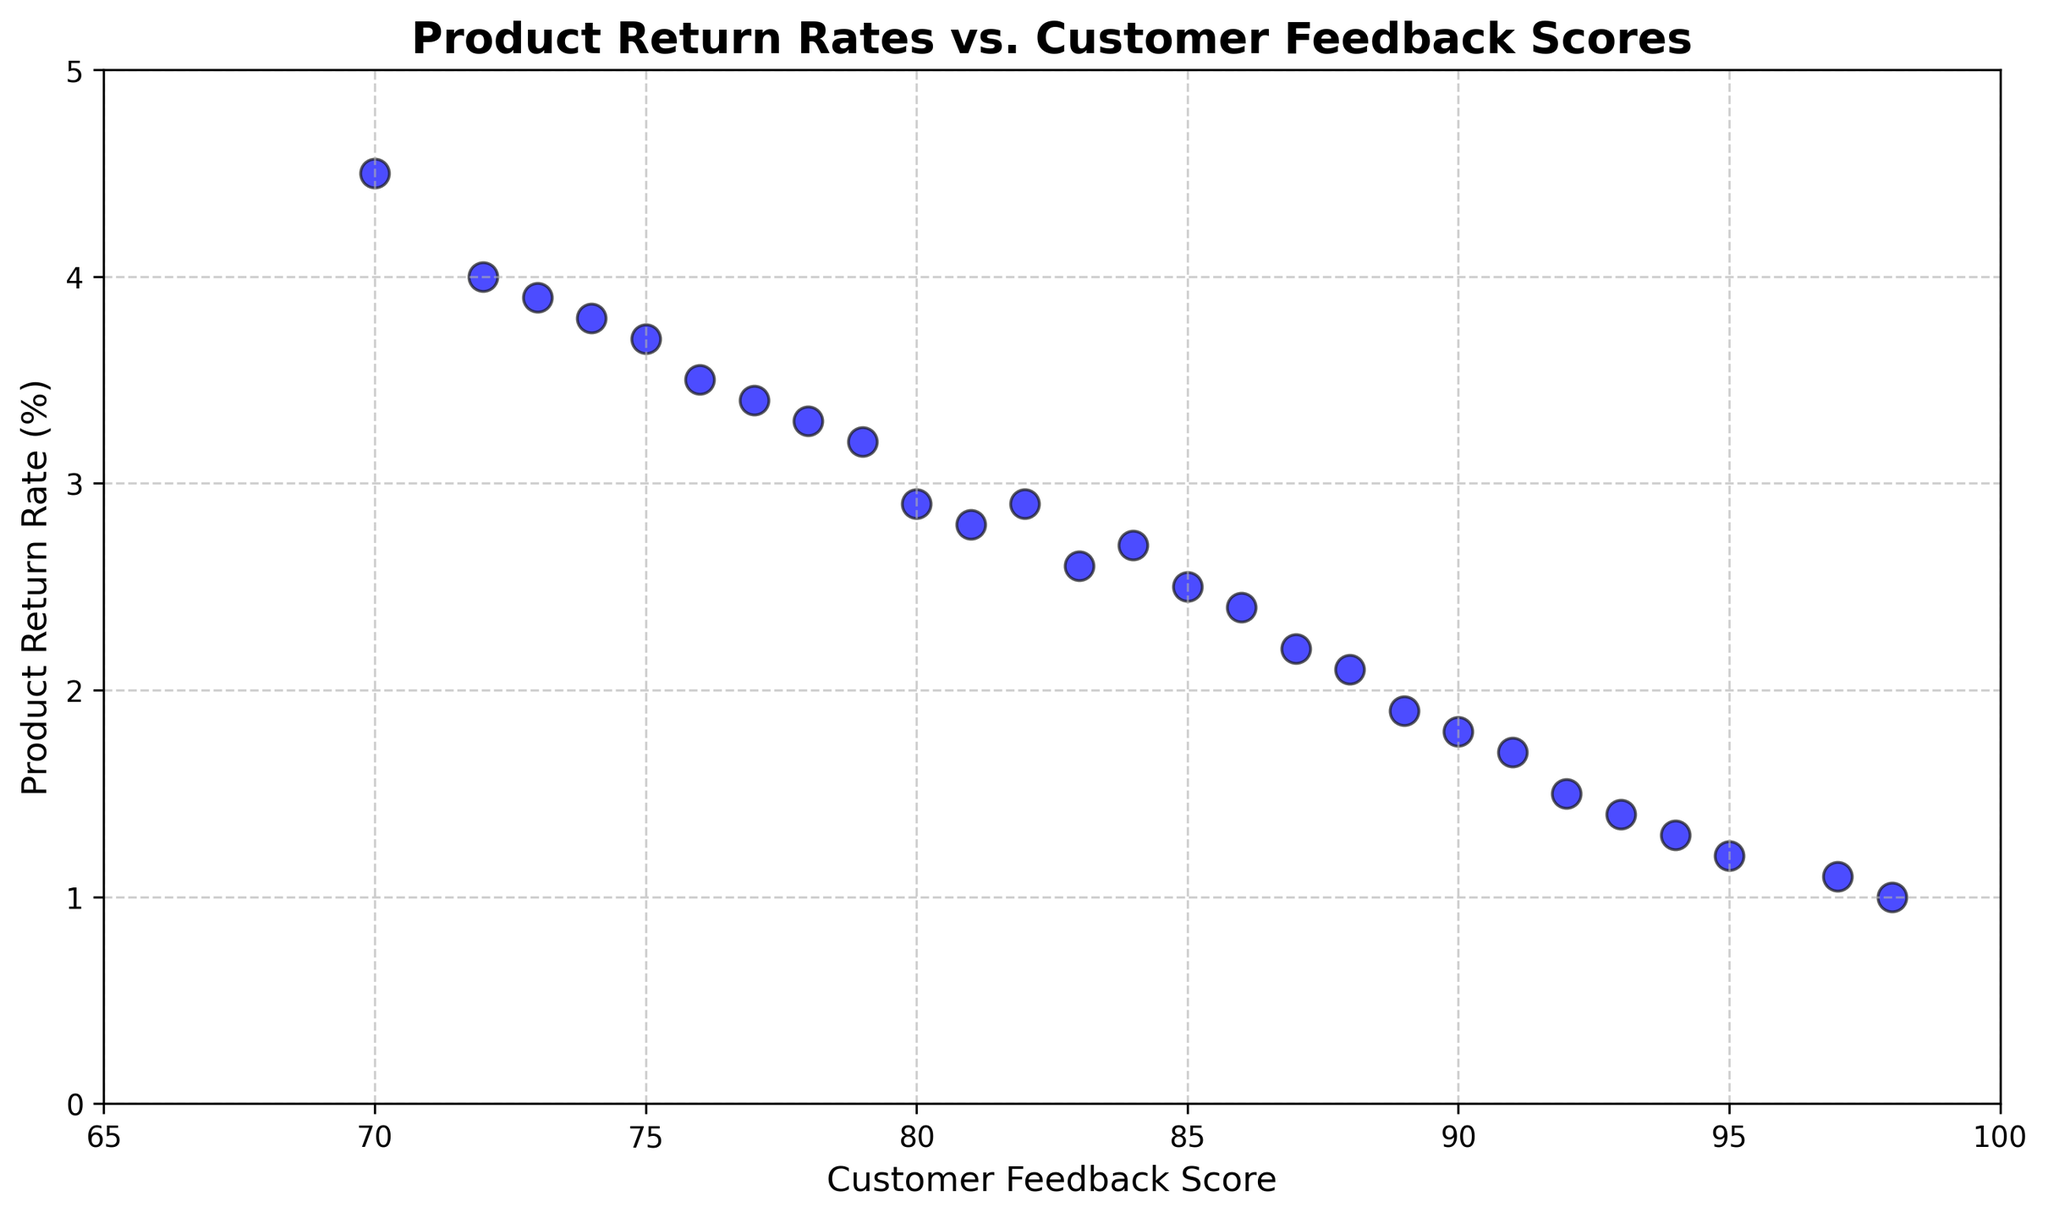what is the range of Product Return Rates? The maximum and minimum values of Product Return Rates are shown in the scatter plot. The minimum is just above 1, and the maximum is near 4.5. Subtract the minimum from the maximum to get the range.
Answer: 4.5 - 1 = 3.5 Which Customer Feedback Score has the highest Product Return Rate? By examining the scatter plot, locate the highest point on the Product Return Rate axis and then trace it back to find the corresponding Customer Feedback Score. The highest Product Return Rate is around 4.5, corresponding to the Customer Feedback Score of 70.
Answer: 70 Do higher Customer Feedback Scores generally correlate with lower Product Return Rates? Observing the trend, the data points show that as the Customer Feedback Scores increase, the Product Return Rates generally decrease. This can be seen by the downward trend of points from left to right.
Answer: Yes Comparing Customer Feedback Scores of 90 and 75, which one has a lower Product Return Rate? Locate the points for Customer Feedback Scores of 90 and 75 on the scatter plot. The Product Return Rate for 90 is about 1.8, while for 75 it's around 3.7. Therefore, 90 has a lower Product Return Rate.
Answer: 90 What is the average Product Return Rate for Customer Feedback Scores between 85 to 95? Identify the points within the 85 to 95 range. The Product Return Rates are 2.5, 1.8, 2.1, 1.5, 2.4, 2.6, 1.9, 1.3, and 1.7. Sum these values and then divide by the number of points.
Answer: (2.5 + 1.8 + 2.1 + 1.5 + 2.4 + 2.6 + 1.9 + 1.3 + 1.7) / 9 ≈ 2.10 Is there any point with a Customer Feedback Score of 95? What is its Product Return Rate? Check the scatter plot for the point where the Customer Feedback Score is 95. The corresponding Product Return Rate is around 1.2.
Answer: Yes, 1.2 How many Customer Feedback Scores are above 90, and what is their average Product Return Rate? Count the number of data points with Customer Feedback Scores higher than 90 (92, 93, 94, 95, 97, 98). The Product Return Rates are 1.5, 1.4, 1.3, 1.2, 1.1, and 1.0. Sum these values and divide by 6.
Answer: 6, (1.5 + 1.4 + 1.3 + 1.2 + 1.1 + 1.0) / 6 ≈ 1.25 